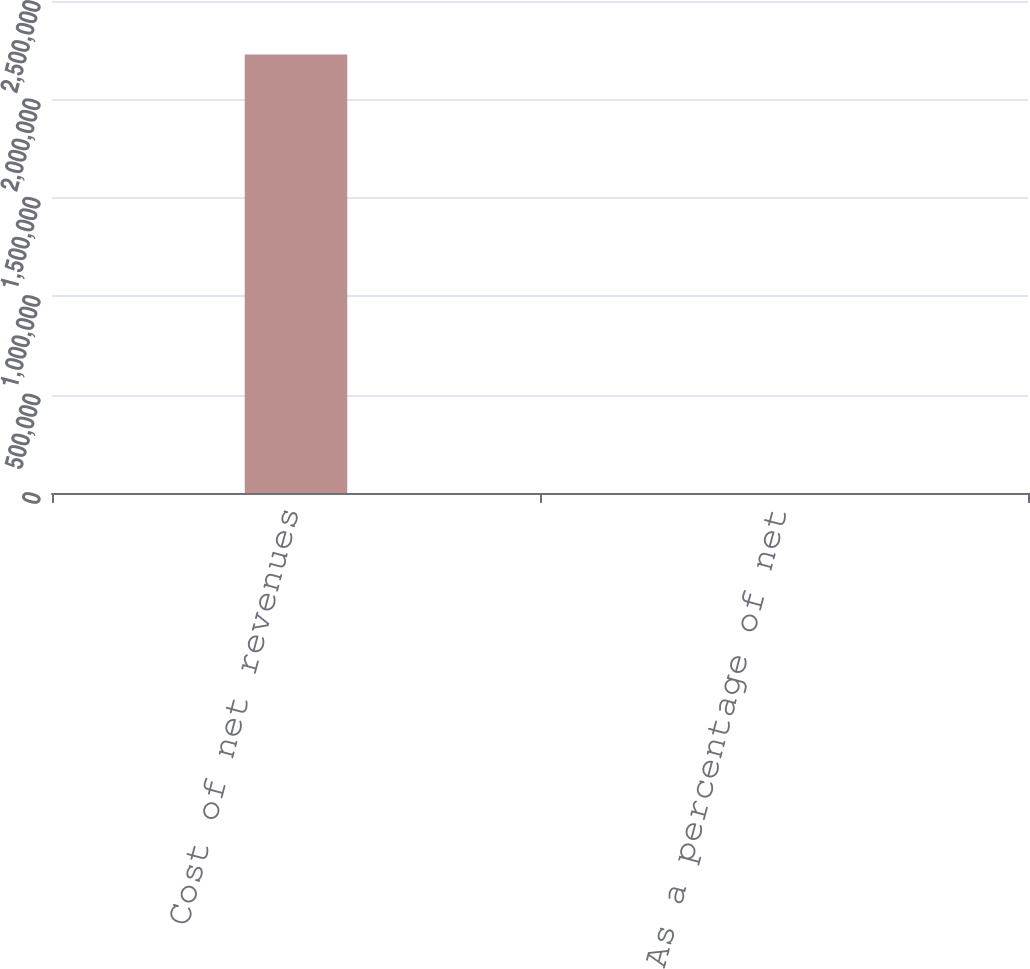Convert chart. <chart><loc_0><loc_0><loc_500><loc_500><bar_chart><fcel>Cost of net revenues<fcel>As a percentage of net<nl><fcel>2.22807e+06<fcel>26.1<nl></chart> 